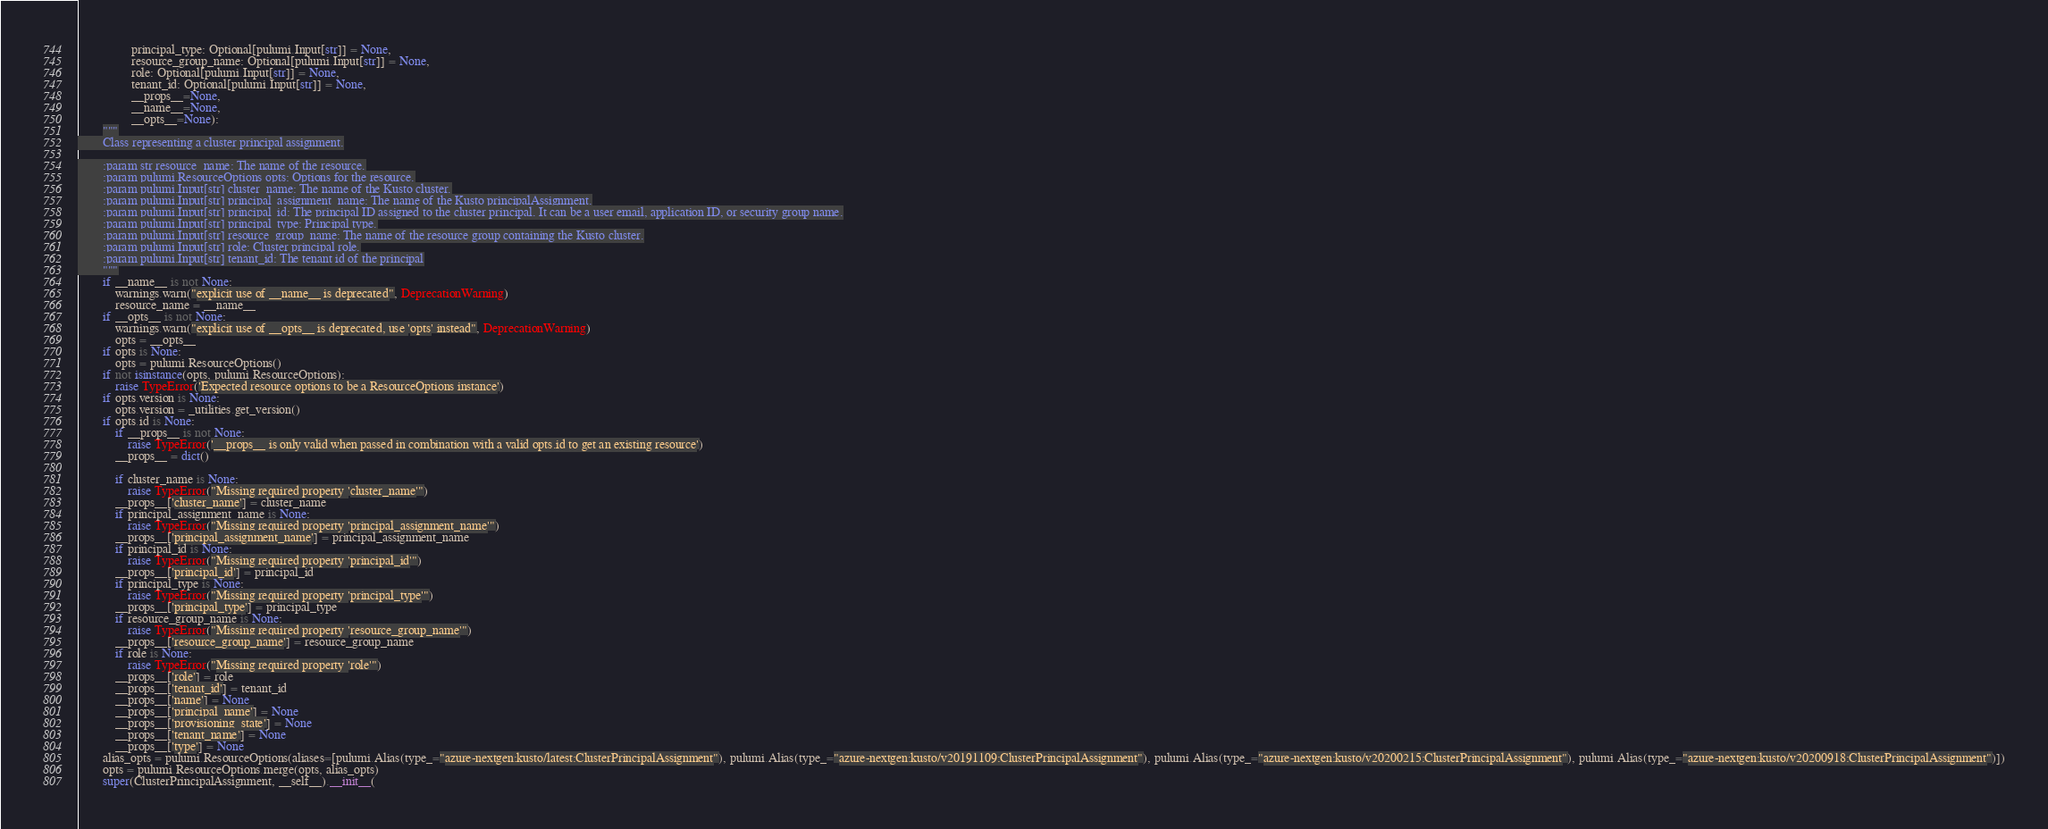<code> <loc_0><loc_0><loc_500><loc_500><_Python_>                 principal_type: Optional[pulumi.Input[str]] = None,
                 resource_group_name: Optional[pulumi.Input[str]] = None,
                 role: Optional[pulumi.Input[str]] = None,
                 tenant_id: Optional[pulumi.Input[str]] = None,
                 __props__=None,
                 __name__=None,
                 __opts__=None):
        """
        Class representing a cluster principal assignment.

        :param str resource_name: The name of the resource.
        :param pulumi.ResourceOptions opts: Options for the resource.
        :param pulumi.Input[str] cluster_name: The name of the Kusto cluster.
        :param pulumi.Input[str] principal_assignment_name: The name of the Kusto principalAssignment.
        :param pulumi.Input[str] principal_id: The principal ID assigned to the cluster principal. It can be a user email, application ID, or security group name.
        :param pulumi.Input[str] principal_type: Principal type.
        :param pulumi.Input[str] resource_group_name: The name of the resource group containing the Kusto cluster.
        :param pulumi.Input[str] role: Cluster principal role.
        :param pulumi.Input[str] tenant_id: The tenant id of the principal
        """
        if __name__ is not None:
            warnings.warn("explicit use of __name__ is deprecated", DeprecationWarning)
            resource_name = __name__
        if __opts__ is not None:
            warnings.warn("explicit use of __opts__ is deprecated, use 'opts' instead", DeprecationWarning)
            opts = __opts__
        if opts is None:
            opts = pulumi.ResourceOptions()
        if not isinstance(opts, pulumi.ResourceOptions):
            raise TypeError('Expected resource options to be a ResourceOptions instance')
        if opts.version is None:
            opts.version = _utilities.get_version()
        if opts.id is None:
            if __props__ is not None:
                raise TypeError('__props__ is only valid when passed in combination with a valid opts.id to get an existing resource')
            __props__ = dict()

            if cluster_name is None:
                raise TypeError("Missing required property 'cluster_name'")
            __props__['cluster_name'] = cluster_name
            if principal_assignment_name is None:
                raise TypeError("Missing required property 'principal_assignment_name'")
            __props__['principal_assignment_name'] = principal_assignment_name
            if principal_id is None:
                raise TypeError("Missing required property 'principal_id'")
            __props__['principal_id'] = principal_id
            if principal_type is None:
                raise TypeError("Missing required property 'principal_type'")
            __props__['principal_type'] = principal_type
            if resource_group_name is None:
                raise TypeError("Missing required property 'resource_group_name'")
            __props__['resource_group_name'] = resource_group_name
            if role is None:
                raise TypeError("Missing required property 'role'")
            __props__['role'] = role
            __props__['tenant_id'] = tenant_id
            __props__['name'] = None
            __props__['principal_name'] = None
            __props__['provisioning_state'] = None
            __props__['tenant_name'] = None
            __props__['type'] = None
        alias_opts = pulumi.ResourceOptions(aliases=[pulumi.Alias(type_="azure-nextgen:kusto/latest:ClusterPrincipalAssignment"), pulumi.Alias(type_="azure-nextgen:kusto/v20191109:ClusterPrincipalAssignment"), pulumi.Alias(type_="azure-nextgen:kusto/v20200215:ClusterPrincipalAssignment"), pulumi.Alias(type_="azure-nextgen:kusto/v20200918:ClusterPrincipalAssignment")])
        opts = pulumi.ResourceOptions.merge(opts, alias_opts)
        super(ClusterPrincipalAssignment, __self__).__init__(</code> 